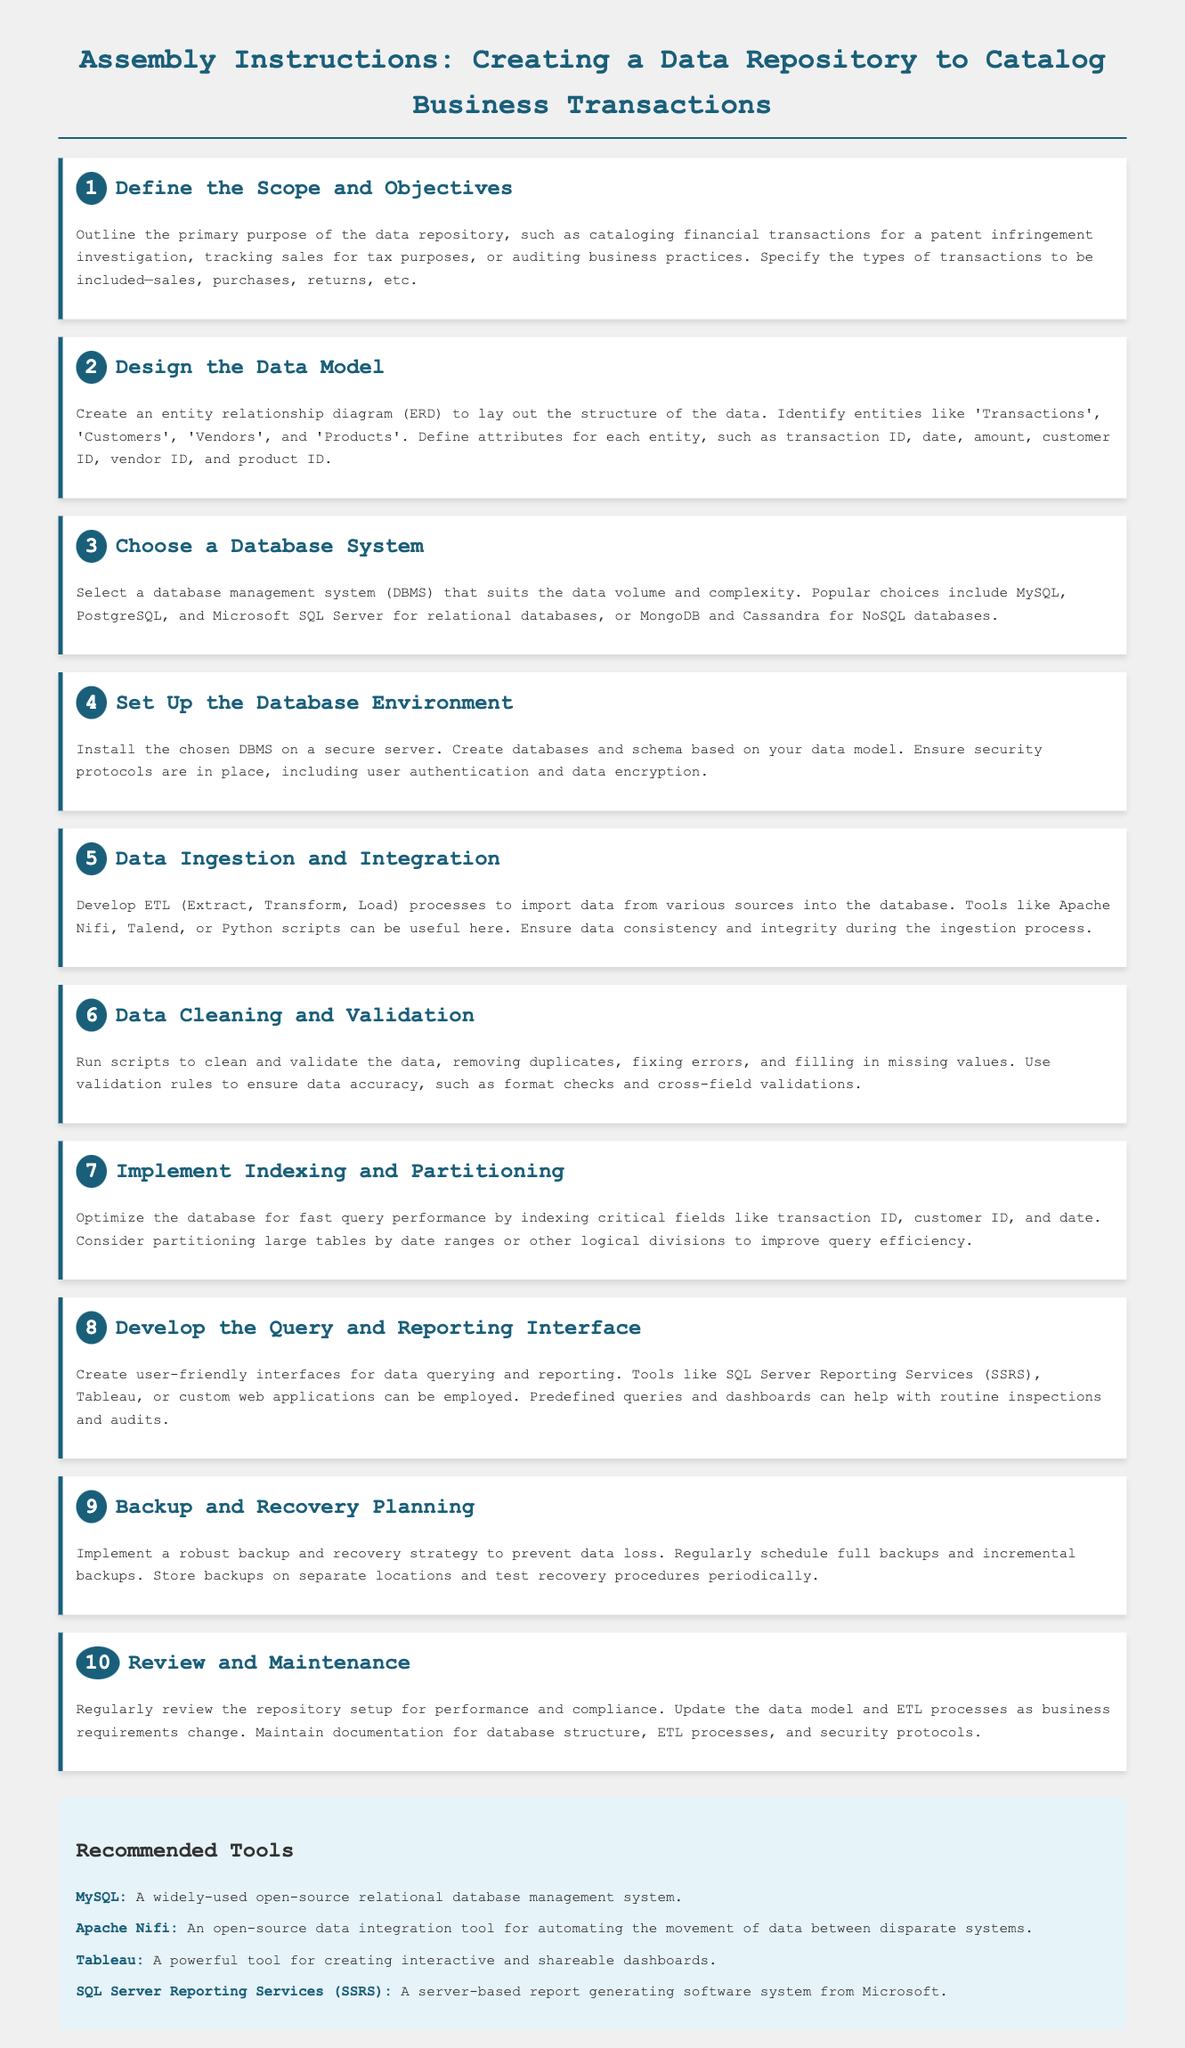What is the primary purpose of the data repository? The primary purpose is to catalog financial transactions for a patent infringement investigation.
Answer: catalog financial transactions for a patent infringement investigation What is the first step in creating a data repository? The first step is to define the scope and objectives.
Answer: define the scope and objectives Which database management system is mentioned for relational databases? MySQL is listed as a popular choice for relational databases.
Answer: MySQL How many steps are involved in creating a data repository? There are a total of ten steps involved.
Answer: ten What ETL process is mentioned in the steps? The data ingestion and integration step mentions the ETL process.
Answer: ETL What tool is recommended for data integration? Apache Nifi is recommended for data integration.
Answer: Apache Nifi What should be implemented to prevent data loss? A robust backup and recovery strategy should be implemented.
Answer: backup and recovery strategy What is created for user-friendly data querying? A query and reporting interface is created for user-friendly data querying.
Answer: query and reporting interface What is a key focus during the data cleaning step? Removing duplicates is a key focus during the data cleaning step.
Answer: removing duplicates What should be regularly reviewed for compliance? The repository setup should be regularly reviewed for performance and compliance.
Answer: repository setup 